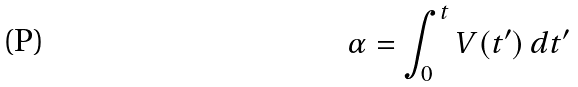<formula> <loc_0><loc_0><loc_500><loc_500>\alpha = \int _ { 0 } ^ { t } V ( t ^ { \prime } ) \, d t ^ { \prime }</formula> 